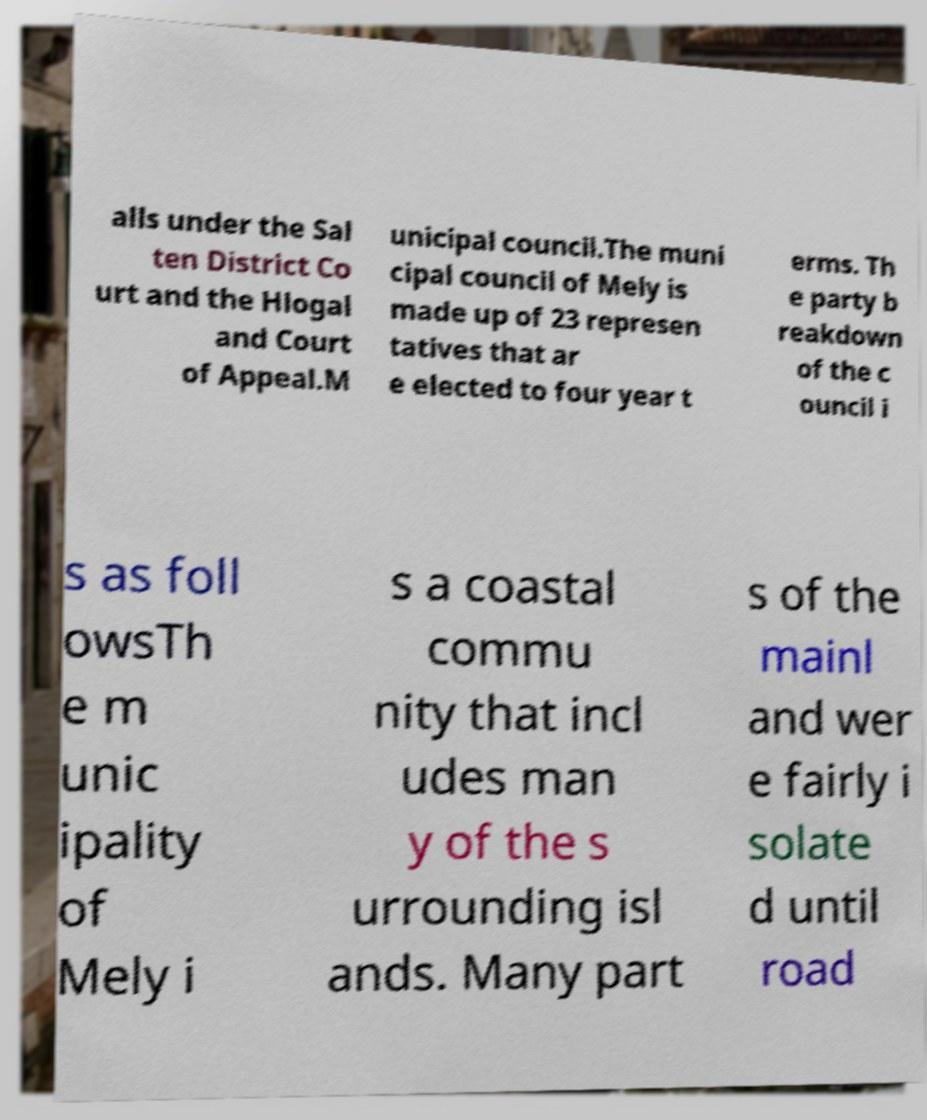I need the written content from this picture converted into text. Can you do that? alls under the Sal ten District Co urt and the Hlogal and Court of Appeal.M unicipal council.The muni cipal council of Mely is made up of 23 represen tatives that ar e elected to four year t erms. Th e party b reakdown of the c ouncil i s as foll owsTh e m unic ipality of Mely i s a coastal commu nity that incl udes man y of the s urrounding isl ands. Many part s of the mainl and wer e fairly i solate d until road 